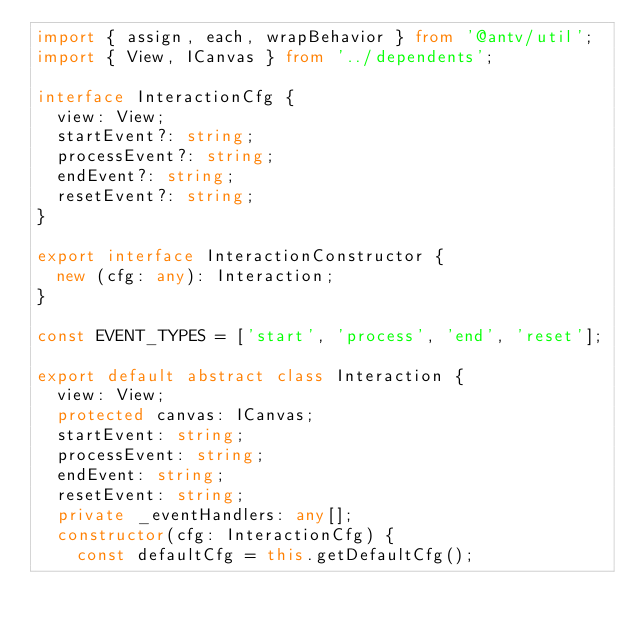Convert code to text. <code><loc_0><loc_0><loc_500><loc_500><_TypeScript_>import { assign, each, wrapBehavior } from '@antv/util';
import { View, ICanvas } from '../dependents';

interface InteractionCfg {
  view: View;
  startEvent?: string;
  processEvent?: string;
  endEvent?: string;
  resetEvent?: string;
}

export interface InteractionConstructor {
  new (cfg: any): Interaction;
}

const EVENT_TYPES = ['start', 'process', 'end', 'reset'];

export default abstract class Interaction {
  view: View;
  protected canvas: ICanvas;
  startEvent: string;
  processEvent: string;
  endEvent: string;
  resetEvent: string;
  private _eventHandlers: any[];
  constructor(cfg: InteractionCfg) {
    const defaultCfg = this.getDefaultCfg();</code> 